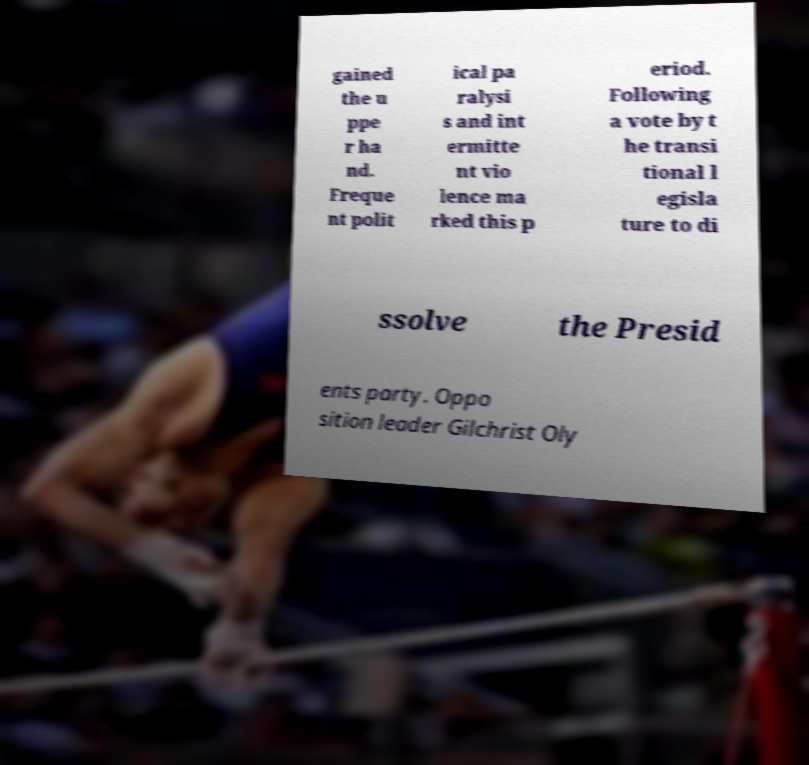Please identify and transcribe the text found in this image. gained the u ppe r ha nd. Freque nt polit ical pa ralysi s and int ermitte nt vio lence ma rked this p eriod. Following a vote by t he transi tional l egisla ture to di ssolve the Presid ents party. Oppo sition leader Gilchrist Oly 